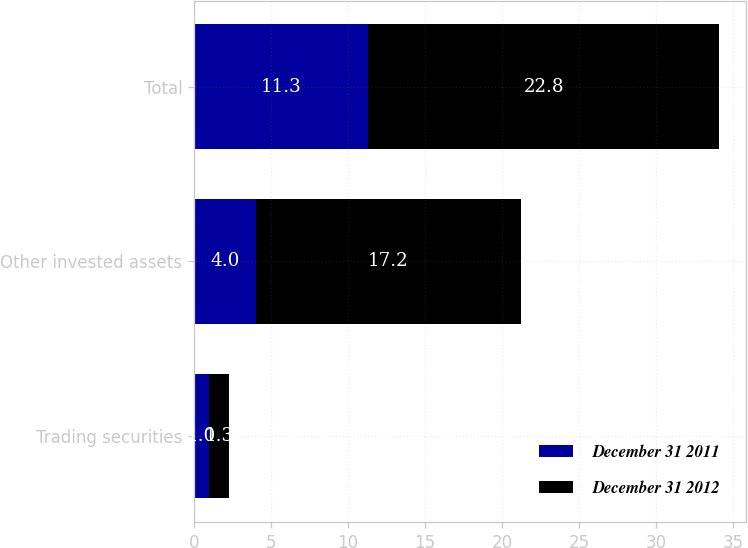Convert chart to OTSL. <chart><loc_0><loc_0><loc_500><loc_500><stacked_bar_chart><ecel><fcel>Trading securities<fcel>Other invested assets<fcel>Total<nl><fcel>December 31 2011<fcel>1<fcel>4<fcel>11.3<nl><fcel>December 31 2012<fcel>1.3<fcel>17.2<fcel>22.8<nl></chart> 